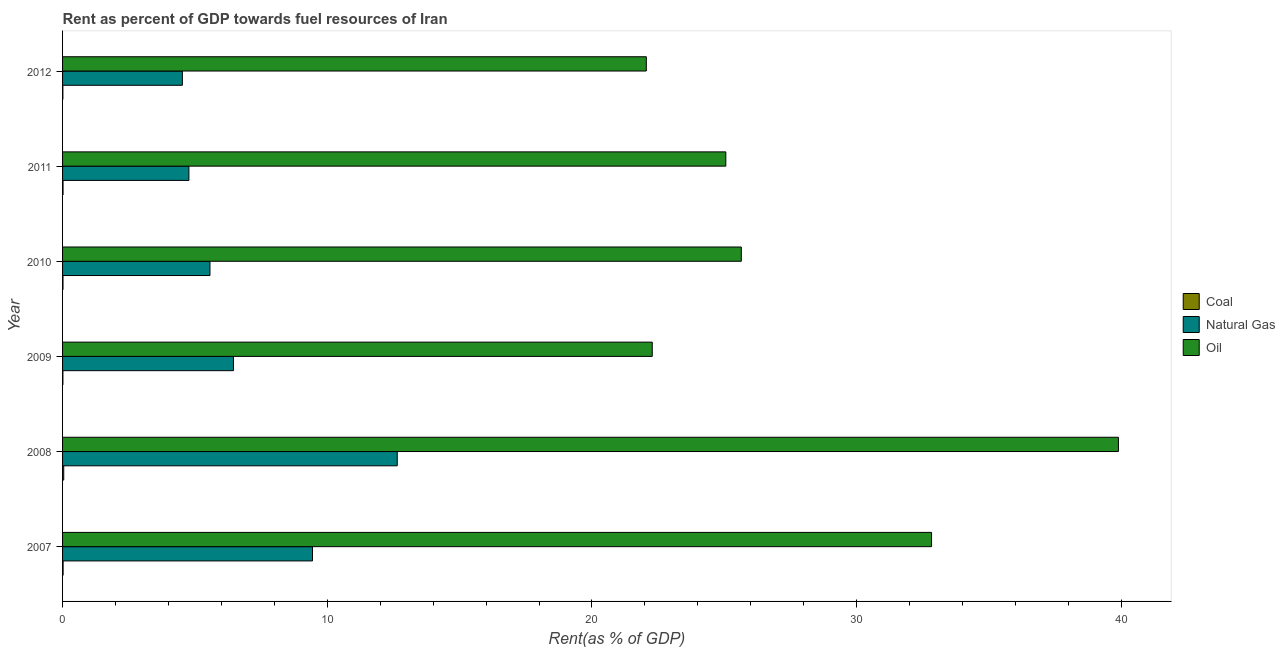How many different coloured bars are there?
Your answer should be very brief. 3. How many groups of bars are there?
Your answer should be very brief. 6. Are the number of bars per tick equal to the number of legend labels?
Give a very brief answer. Yes. How many bars are there on the 1st tick from the bottom?
Your answer should be very brief. 3. In how many cases, is the number of bars for a given year not equal to the number of legend labels?
Ensure brevity in your answer.  0. What is the rent towards natural gas in 2009?
Give a very brief answer. 6.46. Across all years, what is the maximum rent towards natural gas?
Your answer should be very brief. 12.64. Across all years, what is the minimum rent towards oil?
Offer a very short reply. 22.05. In which year was the rent towards oil maximum?
Provide a short and direct response. 2008. In which year was the rent towards natural gas minimum?
Your answer should be compact. 2012. What is the total rent towards natural gas in the graph?
Offer a very short reply. 43.41. What is the difference between the rent towards oil in 2011 and that in 2012?
Provide a short and direct response. 3. What is the difference between the rent towards coal in 2011 and the rent towards natural gas in 2012?
Your answer should be very brief. -4.51. What is the average rent towards coal per year?
Give a very brief answer. 0.02. In the year 2010, what is the difference between the rent towards coal and rent towards oil?
Make the answer very short. -25.62. In how many years, is the rent towards oil greater than 10 %?
Keep it short and to the point. 6. What is the ratio of the rent towards coal in 2010 to that in 2011?
Ensure brevity in your answer.  0.91. Is the difference between the rent towards oil in 2007 and 2010 greater than the difference between the rent towards coal in 2007 and 2010?
Ensure brevity in your answer.  Yes. What is the difference between the highest and the second highest rent towards coal?
Provide a succinct answer. 0.02. What is the difference between the highest and the lowest rent towards oil?
Your answer should be compact. 17.84. In how many years, is the rent towards oil greater than the average rent towards oil taken over all years?
Give a very brief answer. 2. Is the sum of the rent towards oil in 2007 and 2009 greater than the maximum rent towards coal across all years?
Keep it short and to the point. Yes. What does the 1st bar from the top in 2012 represents?
Provide a succinct answer. Oil. What does the 1st bar from the bottom in 2007 represents?
Keep it short and to the point. Coal. Is it the case that in every year, the sum of the rent towards coal and rent towards natural gas is greater than the rent towards oil?
Your answer should be very brief. No. How many bars are there?
Your answer should be compact. 18. How many years are there in the graph?
Offer a very short reply. 6. Are the values on the major ticks of X-axis written in scientific E-notation?
Provide a short and direct response. No. Does the graph contain grids?
Keep it short and to the point. No. How many legend labels are there?
Your answer should be compact. 3. How are the legend labels stacked?
Keep it short and to the point. Vertical. What is the title of the graph?
Offer a terse response. Rent as percent of GDP towards fuel resources of Iran. Does "Ages 20-50" appear as one of the legend labels in the graph?
Provide a succinct answer. No. What is the label or title of the X-axis?
Keep it short and to the point. Rent(as % of GDP). What is the Rent(as % of GDP) in Coal in 2007?
Your response must be concise. 0.02. What is the Rent(as % of GDP) in Natural Gas in 2007?
Make the answer very short. 9.44. What is the Rent(as % of GDP) in Oil in 2007?
Give a very brief answer. 32.83. What is the Rent(as % of GDP) in Coal in 2008?
Offer a very short reply. 0.04. What is the Rent(as % of GDP) in Natural Gas in 2008?
Give a very brief answer. 12.64. What is the Rent(as % of GDP) in Oil in 2008?
Give a very brief answer. 39.89. What is the Rent(as % of GDP) in Coal in 2009?
Keep it short and to the point. 0.01. What is the Rent(as % of GDP) of Natural Gas in 2009?
Your answer should be compact. 6.46. What is the Rent(as % of GDP) of Oil in 2009?
Your response must be concise. 22.28. What is the Rent(as % of GDP) of Coal in 2010?
Offer a terse response. 0.02. What is the Rent(as % of GDP) in Natural Gas in 2010?
Offer a very short reply. 5.57. What is the Rent(as % of GDP) in Oil in 2010?
Provide a short and direct response. 25.64. What is the Rent(as % of GDP) in Coal in 2011?
Give a very brief answer. 0.02. What is the Rent(as % of GDP) in Natural Gas in 2011?
Make the answer very short. 4.77. What is the Rent(as % of GDP) of Oil in 2011?
Provide a succinct answer. 25.06. What is the Rent(as % of GDP) of Coal in 2012?
Provide a succinct answer. 0.01. What is the Rent(as % of GDP) of Natural Gas in 2012?
Your response must be concise. 4.53. What is the Rent(as % of GDP) in Oil in 2012?
Make the answer very short. 22.05. Across all years, what is the maximum Rent(as % of GDP) of Coal?
Give a very brief answer. 0.04. Across all years, what is the maximum Rent(as % of GDP) of Natural Gas?
Provide a succinct answer. 12.64. Across all years, what is the maximum Rent(as % of GDP) in Oil?
Offer a terse response. 39.89. Across all years, what is the minimum Rent(as % of GDP) of Coal?
Your answer should be very brief. 0.01. Across all years, what is the minimum Rent(as % of GDP) of Natural Gas?
Provide a succinct answer. 4.53. Across all years, what is the minimum Rent(as % of GDP) of Oil?
Your response must be concise. 22.05. What is the total Rent(as % of GDP) of Coal in the graph?
Keep it short and to the point. 0.12. What is the total Rent(as % of GDP) in Natural Gas in the graph?
Provide a succinct answer. 43.41. What is the total Rent(as % of GDP) in Oil in the graph?
Your response must be concise. 167.74. What is the difference between the Rent(as % of GDP) in Coal in 2007 and that in 2008?
Offer a very short reply. -0.02. What is the difference between the Rent(as % of GDP) in Natural Gas in 2007 and that in 2008?
Offer a terse response. -3.2. What is the difference between the Rent(as % of GDP) in Oil in 2007 and that in 2008?
Keep it short and to the point. -7.06. What is the difference between the Rent(as % of GDP) of Coal in 2007 and that in 2009?
Keep it short and to the point. 0.01. What is the difference between the Rent(as % of GDP) of Natural Gas in 2007 and that in 2009?
Your answer should be compact. 2.99. What is the difference between the Rent(as % of GDP) of Oil in 2007 and that in 2009?
Your answer should be very brief. 10.55. What is the difference between the Rent(as % of GDP) in Coal in 2007 and that in 2010?
Your answer should be compact. 0. What is the difference between the Rent(as % of GDP) of Natural Gas in 2007 and that in 2010?
Your answer should be compact. 3.87. What is the difference between the Rent(as % of GDP) of Oil in 2007 and that in 2010?
Provide a succinct answer. 7.19. What is the difference between the Rent(as % of GDP) of Coal in 2007 and that in 2011?
Make the answer very short. 0. What is the difference between the Rent(as % of GDP) of Natural Gas in 2007 and that in 2011?
Make the answer very short. 4.67. What is the difference between the Rent(as % of GDP) of Oil in 2007 and that in 2011?
Offer a terse response. 7.77. What is the difference between the Rent(as % of GDP) of Coal in 2007 and that in 2012?
Give a very brief answer. 0.01. What is the difference between the Rent(as % of GDP) in Natural Gas in 2007 and that in 2012?
Your answer should be compact. 4.92. What is the difference between the Rent(as % of GDP) of Oil in 2007 and that in 2012?
Your response must be concise. 10.78. What is the difference between the Rent(as % of GDP) of Coal in 2008 and that in 2009?
Give a very brief answer. 0.03. What is the difference between the Rent(as % of GDP) of Natural Gas in 2008 and that in 2009?
Provide a succinct answer. 6.19. What is the difference between the Rent(as % of GDP) in Oil in 2008 and that in 2009?
Your answer should be very brief. 17.61. What is the difference between the Rent(as % of GDP) of Coal in 2008 and that in 2010?
Keep it short and to the point. 0.03. What is the difference between the Rent(as % of GDP) in Natural Gas in 2008 and that in 2010?
Give a very brief answer. 7.07. What is the difference between the Rent(as % of GDP) of Oil in 2008 and that in 2010?
Your answer should be compact. 14.25. What is the difference between the Rent(as % of GDP) in Coal in 2008 and that in 2011?
Your answer should be compact. 0.03. What is the difference between the Rent(as % of GDP) of Natural Gas in 2008 and that in 2011?
Keep it short and to the point. 7.87. What is the difference between the Rent(as % of GDP) in Oil in 2008 and that in 2011?
Ensure brevity in your answer.  14.83. What is the difference between the Rent(as % of GDP) of Coal in 2008 and that in 2012?
Make the answer very short. 0.03. What is the difference between the Rent(as % of GDP) in Natural Gas in 2008 and that in 2012?
Offer a terse response. 8.12. What is the difference between the Rent(as % of GDP) in Oil in 2008 and that in 2012?
Your answer should be very brief. 17.84. What is the difference between the Rent(as % of GDP) of Coal in 2009 and that in 2010?
Ensure brevity in your answer.  -0. What is the difference between the Rent(as % of GDP) of Natural Gas in 2009 and that in 2010?
Your response must be concise. 0.89. What is the difference between the Rent(as % of GDP) of Oil in 2009 and that in 2010?
Provide a succinct answer. -3.36. What is the difference between the Rent(as % of GDP) in Coal in 2009 and that in 2011?
Ensure brevity in your answer.  -0.01. What is the difference between the Rent(as % of GDP) of Natural Gas in 2009 and that in 2011?
Your answer should be very brief. 1.68. What is the difference between the Rent(as % of GDP) in Oil in 2009 and that in 2011?
Your response must be concise. -2.78. What is the difference between the Rent(as % of GDP) in Coal in 2009 and that in 2012?
Offer a terse response. 0. What is the difference between the Rent(as % of GDP) of Natural Gas in 2009 and that in 2012?
Make the answer very short. 1.93. What is the difference between the Rent(as % of GDP) in Oil in 2009 and that in 2012?
Provide a short and direct response. 0.22. What is the difference between the Rent(as % of GDP) in Coal in 2010 and that in 2011?
Your response must be concise. -0. What is the difference between the Rent(as % of GDP) of Natural Gas in 2010 and that in 2011?
Make the answer very short. 0.8. What is the difference between the Rent(as % of GDP) of Oil in 2010 and that in 2011?
Ensure brevity in your answer.  0.59. What is the difference between the Rent(as % of GDP) of Coal in 2010 and that in 2012?
Ensure brevity in your answer.  0. What is the difference between the Rent(as % of GDP) in Natural Gas in 2010 and that in 2012?
Your response must be concise. 1.04. What is the difference between the Rent(as % of GDP) of Oil in 2010 and that in 2012?
Offer a terse response. 3.59. What is the difference between the Rent(as % of GDP) of Coal in 2011 and that in 2012?
Offer a very short reply. 0.01. What is the difference between the Rent(as % of GDP) in Natural Gas in 2011 and that in 2012?
Offer a very short reply. 0.25. What is the difference between the Rent(as % of GDP) of Oil in 2011 and that in 2012?
Make the answer very short. 3. What is the difference between the Rent(as % of GDP) of Coal in 2007 and the Rent(as % of GDP) of Natural Gas in 2008?
Provide a short and direct response. -12.62. What is the difference between the Rent(as % of GDP) in Coal in 2007 and the Rent(as % of GDP) in Oil in 2008?
Your answer should be compact. -39.87. What is the difference between the Rent(as % of GDP) in Natural Gas in 2007 and the Rent(as % of GDP) in Oil in 2008?
Provide a succinct answer. -30.45. What is the difference between the Rent(as % of GDP) of Coal in 2007 and the Rent(as % of GDP) of Natural Gas in 2009?
Make the answer very short. -6.44. What is the difference between the Rent(as % of GDP) in Coal in 2007 and the Rent(as % of GDP) in Oil in 2009?
Your answer should be very brief. -22.26. What is the difference between the Rent(as % of GDP) in Natural Gas in 2007 and the Rent(as % of GDP) in Oil in 2009?
Provide a succinct answer. -12.84. What is the difference between the Rent(as % of GDP) of Coal in 2007 and the Rent(as % of GDP) of Natural Gas in 2010?
Your response must be concise. -5.55. What is the difference between the Rent(as % of GDP) in Coal in 2007 and the Rent(as % of GDP) in Oil in 2010?
Keep it short and to the point. -25.62. What is the difference between the Rent(as % of GDP) in Natural Gas in 2007 and the Rent(as % of GDP) in Oil in 2010?
Provide a short and direct response. -16.2. What is the difference between the Rent(as % of GDP) of Coal in 2007 and the Rent(as % of GDP) of Natural Gas in 2011?
Give a very brief answer. -4.75. What is the difference between the Rent(as % of GDP) of Coal in 2007 and the Rent(as % of GDP) of Oil in 2011?
Keep it short and to the point. -25.04. What is the difference between the Rent(as % of GDP) in Natural Gas in 2007 and the Rent(as % of GDP) in Oil in 2011?
Your answer should be very brief. -15.61. What is the difference between the Rent(as % of GDP) in Coal in 2007 and the Rent(as % of GDP) in Natural Gas in 2012?
Provide a short and direct response. -4.51. What is the difference between the Rent(as % of GDP) of Coal in 2007 and the Rent(as % of GDP) of Oil in 2012?
Offer a very short reply. -22.03. What is the difference between the Rent(as % of GDP) in Natural Gas in 2007 and the Rent(as % of GDP) in Oil in 2012?
Offer a terse response. -12.61. What is the difference between the Rent(as % of GDP) of Coal in 2008 and the Rent(as % of GDP) of Natural Gas in 2009?
Your response must be concise. -6.41. What is the difference between the Rent(as % of GDP) of Coal in 2008 and the Rent(as % of GDP) of Oil in 2009?
Ensure brevity in your answer.  -22.23. What is the difference between the Rent(as % of GDP) of Natural Gas in 2008 and the Rent(as % of GDP) of Oil in 2009?
Your answer should be very brief. -9.63. What is the difference between the Rent(as % of GDP) in Coal in 2008 and the Rent(as % of GDP) in Natural Gas in 2010?
Keep it short and to the point. -5.52. What is the difference between the Rent(as % of GDP) of Coal in 2008 and the Rent(as % of GDP) of Oil in 2010?
Your answer should be compact. -25.6. What is the difference between the Rent(as % of GDP) of Natural Gas in 2008 and the Rent(as % of GDP) of Oil in 2010?
Offer a very short reply. -13. What is the difference between the Rent(as % of GDP) of Coal in 2008 and the Rent(as % of GDP) of Natural Gas in 2011?
Provide a succinct answer. -4.73. What is the difference between the Rent(as % of GDP) in Coal in 2008 and the Rent(as % of GDP) in Oil in 2011?
Provide a succinct answer. -25.01. What is the difference between the Rent(as % of GDP) in Natural Gas in 2008 and the Rent(as % of GDP) in Oil in 2011?
Your answer should be compact. -12.41. What is the difference between the Rent(as % of GDP) in Coal in 2008 and the Rent(as % of GDP) in Natural Gas in 2012?
Your answer should be very brief. -4.48. What is the difference between the Rent(as % of GDP) in Coal in 2008 and the Rent(as % of GDP) in Oil in 2012?
Your answer should be very brief. -22.01. What is the difference between the Rent(as % of GDP) in Natural Gas in 2008 and the Rent(as % of GDP) in Oil in 2012?
Offer a very short reply. -9.41. What is the difference between the Rent(as % of GDP) of Coal in 2009 and the Rent(as % of GDP) of Natural Gas in 2010?
Offer a terse response. -5.56. What is the difference between the Rent(as % of GDP) in Coal in 2009 and the Rent(as % of GDP) in Oil in 2010?
Ensure brevity in your answer.  -25.63. What is the difference between the Rent(as % of GDP) in Natural Gas in 2009 and the Rent(as % of GDP) in Oil in 2010?
Your response must be concise. -19.19. What is the difference between the Rent(as % of GDP) in Coal in 2009 and the Rent(as % of GDP) in Natural Gas in 2011?
Offer a terse response. -4.76. What is the difference between the Rent(as % of GDP) in Coal in 2009 and the Rent(as % of GDP) in Oil in 2011?
Offer a very short reply. -25.04. What is the difference between the Rent(as % of GDP) of Natural Gas in 2009 and the Rent(as % of GDP) of Oil in 2011?
Ensure brevity in your answer.  -18.6. What is the difference between the Rent(as % of GDP) in Coal in 2009 and the Rent(as % of GDP) in Natural Gas in 2012?
Offer a terse response. -4.51. What is the difference between the Rent(as % of GDP) of Coal in 2009 and the Rent(as % of GDP) of Oil in 2012?
Give a very brief answer. -22.04. What is the difference between the Rent(as % of GDP) of Natural Gas in 2009 and the Rent(as % of GDP) of Oil in 2012?
Ensure brevity in your answer.  -15.6. What is the difference between the Rent(as % of GDP) of Coal in 2010 and the Rent(as % of GDP) of Natural Gas in 2011?
Make the answer very short. -4.76. What is the difference between the Rent(as % of GDP) in Coal in 2010 and the Rent(as % of GDP) in Oil in 2011?
Your response must be concise. -25.04. What is the difference between the Rent(as % of GDP) in Natural Gas in 2010 and the Rent(as % of GDP) in Oil in 2011?
Your response must be concise. -19.49. What is the difference between the Rent(as % of GDP) in Coal in 2010 and the Rent(as % of GDP) in Natural Gas in 2012?
Make the answer very short. -4.51. What is the difference between the Rent(as % of GDP) in Coal in 2010 and the Rent(as % of GDP) in Oil in 2012?
Give a very brief answer. -22.04. What is the difference between the Rent(as % of GDP) of Natural Gas in 2010 and the Rent(as % of GDP) of Oil in 2012?
Make the answer very short. -16.48. What is the difference between the Rent(as % of GDP) in Coal in 2011 and the Rent(as % of GDP) in Natural Gas in 2012?
Offer a very short reply. -4.51. What is the difference between the Rent(as % of GDP) in Coal in 2011 and the Rent(as % of GDP) in Oil in 2012?
Make the answer very short. -22.03. What is the difference between the Rent(as % of GDP) in Natural Gas in 2011 and the Rent(as % of GDP) in Oil in 2012?
Your response must be concise. -17.28. What is the average Rent(as % of GDP) of Coal per year?
Offer a terse response. 0.02. What is the average Rent(as % of GDP) in Natural Gas per year?
Your answer should be compact. 7.23. What is the average Rent(as % of GDP) in Oil per year?
Make the answer very short. 27.96. In the year 2007, what is the difference between the Rent(as % of GDP) in Coal and Rent(as % of GDP) in Natural Gas?
Your answer should be compact. -9.42. In the year 2007, what is the difference between the Rent(as % of GDP) of Coal and Rent(as % of GDP) of Oil?
Ensure brevity in your answer.  -32.81. In the year 2007, what is the difference between the Rent(as % of GDP) of Natural Gas and Rent(as % of GDP) of Oil?
Offer a terse response. -23.39. In the year 2008, what is the difference between the Rent(as % of GDP) in Coal and Rent(as % of GDP) in Natural Gas?
Offer a terse response. -12.6. In the year 2008, what is the difference between the Rent(as % of GDP) in Coal and Rent(as % of GDP) in Oil?
Give a very brief answer. -39.84. In the year 2008, what is the difference between the Rent(as % of GDP) in Natural Gas and Rent(as % of GDP) in Oil?
Ensure brevity in your answer.  -27.24. In the year 2009, what is the difference between the Rent(as % of GDP) in Coal and Rent(as % of GDP) in Natural Gas?
Your answer should be very brief. -6.44. In the year 2009, what is the difference between the Rent(as % of GDP) of Coal and Rent(as % of GDP) of Oil?
Your answer should be very brief. -22.26. In the year 2009, what is the difference between the Rent(as % of GDP) in Natural Gas and Rent(as % of GDP) in Oil?
Offer a very short reply. -15.82. In the year 2010, what is the difference between the Rent(as % of GDP) of Coal and Rent(as % of GDP) of Natural Gas?
Your response must be concise. -5.55. In the year 2010, what is the difference between the Rent(as % of GDP) of Coal and Rent(as % of GDP) of Oil?
Give a very brief answer. -25.62. In the year 2010, what is the difference between the Rent(as % of GDP) of Natural Gas and Rent(as % of GDP) of Oil?
Provide a short and direct response. -20.07. In the year 2011, what is the difference between the Rent(as % of GDP) in Coal and Rent(as % of GDP) in Natural Gas?
Make the answer very short. -4.75. In the year 2011, what is the difference between the Rent(as % of GDP) in Coal and Rent(as % of GDP) in Oil?
Give a very brief answer. -25.04. In the year 2011, what is the difference between the Rent(as % of GDP) in Natural Gas and Rent(as % of GDP) in Oil?
Offer a terse response. -20.28. In the year 2012, what is the difference between the Rent(as % of GDP) in Coal and Rent(as % of GDP) in Natural Gas?
Provide a short and direct response. -4.51. In the year 2012, what is the difference between the Rent(as % of GDP) in Coal and Rent(as % of GDP) in Oil?
Keep it short and to the point. -22.04. In the year 2012, what is the difference between the Rent(as % of GDP) of Natural Gas and Rent(as % of GDP) of Oil?
Your response must be concise. -17.53. What is the ratio of the Rent(as % of GDP) in Coal in 2007 to that in 2008?
Offer a very short reply. 0.46. What is the ratio of the Rent(as % of GDP) in Natural Gas in 2007 to that in 2008?
Your answer should be very brief. 0.75. What is the ratio of the Rent(as % of GDP) in Oil in 2007 to that in 2008?
Ensure brevity in your answer.  0.82. What is the ratio of the Rent(as % of GDP) in Coal in 2007 to that in 2009?
Offer a terse response. 1.62. What is the ratio of the Rent(as % of GDP) of Natural Gas in 2007 to that in 2009?
Your answer should be compact. 1.46. What is the ratio of the Rent(as % of GDP) of Oil in 2007 to that in 2009?
Keep it short and to the point. 1.47. What is the ratio of the Rent(as % of GDP) of Coal in 2007 to that in 2010?
Your answer should be compact. 1.23. What is the ratio of the Rent(as % of GDP) in Natural Gas in 2007 to that in 2010?
Your answer should be compact. 1.7. What is the ratio of the Rent(as % of GDP) of Oil in 2007 to that in 2010?
Your response must be concise. 1.28. What is the ratio of the Rent(as % of GDP) of Coal in 2007 to that in 2011?
Give a very brief answer. 1.12. What is the ratio of the Rent(as % of GDP) of Natural Gas in 2007 to that in 2011?
Your response must be concise. 1.98. What is the ratio of the Rent(as % of GDP) of Oil in 2007 to that in 2011?
Your answer should be compact. 1.31. What is the ratio of the Rent(as % of GDP) in Coal in 2007 to that in 2012?
Ensure brevity in your answer.  1.71. What is the ratio of the Rent(as % of GDP) in Natural Gas in 2007 to that in 2012?
Make the answer very short. 2.09. What is the ratio of the Rent(as % of GDP) of Oil in 2007 to that in 2012?
Ensure brevity in your answer.  1.49. What is the ratio of the Rent(as % of GDP) in Coal in 2008 to that in 2009?
Provide a succinct answer. 3.5. What is the ratio of the Rent(as % of GDP) in Natural Gas in 2008 to that in 2009?
Ensure brevity in your answer.  1.96. What is the ratio of the Rent(as % of GDP) of Oil in 2008 to that in 2009?
Your answer should be very brief. 1.79. What is the ratio of the Rent(as % of GDP) in Coal in 2008 to that in 2010?
Provide a succinct answer. 2.65. What is the ratio of the Rent(as % of GDP) in Natural Gas in 2008 to that in 2010?
Your answer should be very brief. 2.27. What is the ratio of the Rent(as % of GDP) in Oil in 2008 to that in 2010?
Keep it short and to the point. 1.56. What is the ratio of the Rent(as % of GDP) in Coal in 2008 to that in 2011?
Give a very brief answer. 2.42. What is the ratio of the Rent(as % of GDP) in Natural Gas in 2008 to that in 2011?
Your answer should be very brief. 2.65. What is the ratio of the Rent(as % of GDP) of Oil in 2008 to that in 2011?
Your answer should be very brief. 1.59. What is the ratio of the Rent(as % of GDP) in Coal in 2008 to that in 2012?
Your answer should be very brief. 3.69. What is the ratio of the Rent(as % of GDP) in Natural Gas in 2008 to that in 2012?
Your answer should be very brief. 2.79. What is the ratio of the Rent(as % of GDP) in Oil in 2008 to that in 2012?
Offer a very short reply. 1.81. What is the ratio of the Rent(as % of GDP) of Coal in 2009 to that in 2010?
Your response must be concise. 0.76. What is the ratio of the Rent(as % of GDP) in Natural Gas in 2009 to that in 2010?
Offer a very short reply. 1.16. What is the ratio of the Rent(as % of GDP) of Oil in 2009 to that in 2010?
Make the answer very short. 0.87. What is the ratio of the Rent(as % of GDP) of Coal in 2009 to that in 2011?
Offer a terse response. 0.69. What is the ratio of the Rent(as % of GDP) in Natural Gas in 2009 to that in 2011?
Give a very brief answer. 1.35. What is the ratio of the Rent(as % of GDP) in Oil in 2009 to that in 2011?
Provide a short and direct response. 0.89. What is the ratio of the Rent(as % of GDP) in Coal in 2009 to that in 2012?
Your answer should be very brief. 1.06. What is the ratio of the Rent(as % of GDP) of Natural Gas in 2009 to that in 2012?
Offer a terse response. 1.43. What is the ratio of the Rent(as % of GDP) of Oil in 2009 to that in 2012?
Keep it short and to the point. 1.01. What is the ratio of the Rent(as % of GDP) of Coal in 2010 to that in 2011?
Offer a very short reply. 0.91. What is the ratio of the Rent(as % of GDP) of Natural Gas in 2010 to that in 2011?
Give a very brief answer. 1.17. What is the ratio of the Rent(as % of GDP) in Oil in 2010 to that in 2011?
Your answer should be compact. 1.02. What is the ratio of the Rent(as % of GDP) of Coal in 2010 to that in 2012?
Give a very brief answer. 1.39. What is the ratio of the Rent(as % of GDP) of Natural Gas in 2010 to that in 2012?
Your answer should be compact. 1.23. What is the ratio of the Rent(as % of GDP) of Oil in 2010 to that in 2012?
Offer a terse response. 1.16. What is the ratio of the Rent(as % of GDP) of Coal in 2011 to that in 2012?
Keep it short and to the point. 1.53. What is the ratio of the Rent(as % of GDP) of Natural Gas in 2011 to that in 2012?
Your answer should be very brief. 1.05. What is the ratio of the Rent(as % of GDP) in Oil in 2011 to that in 2012?
Your response must be concise. 1.14. What is the difference between the highest and the second highest Rent(as % of GDP) of Coal?
Give a very brief answer. 0.02. What is the difference between the highest and the second highest Rent(as % of GDP) of Natural Gas?
Provide a short and direct response. 3.2. What is the difference between the highest and the second highest Rent(as % of GDP) of Oil?
Keep it short and to the point. 7.06. What is the difference between the highest and the lowest Rent(as % of GDP) of Coal?
Provide a short and direct response. 0.03. What is the difference between the highest and the lowest Rent(as % of GDP) of Natural Gas?
Provide a succinct answer. 8.12. What is the difference between the highest and the lowest Rent(as % of GDP) of Oil?
Ensure brevity in your answer.  17.84. 